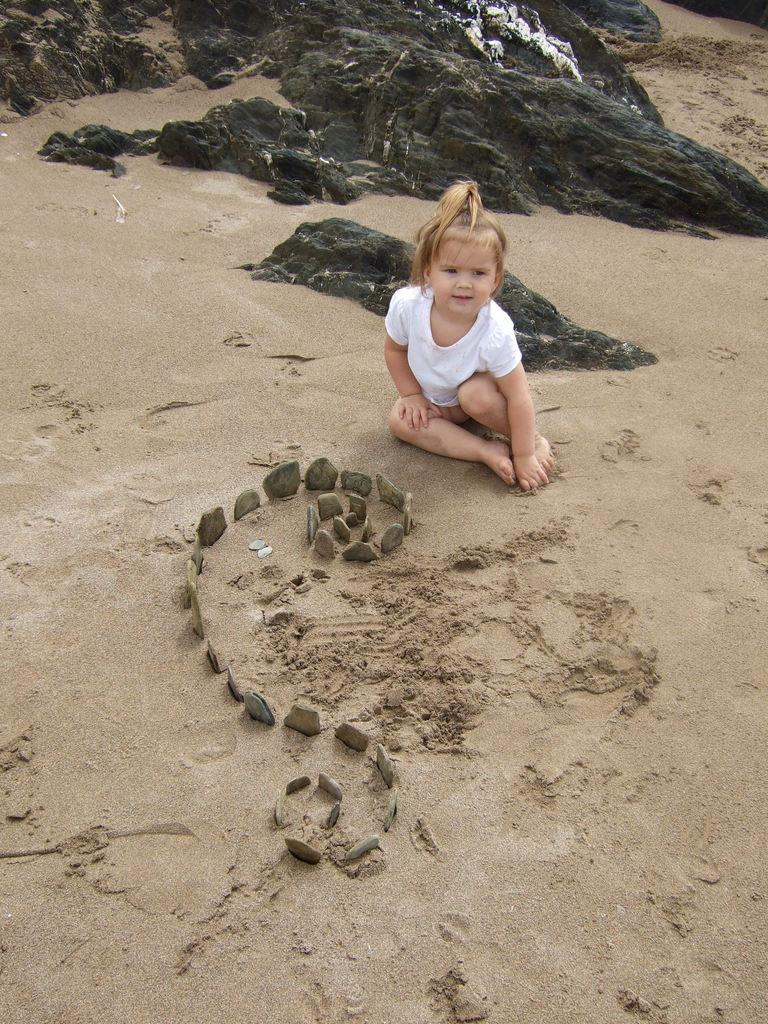What is the main subject of the image? There is a baby in the image. Where is the baby sitting? The baby is sitting on the sand. What can be seen in front of the baby? There are stones in front of the baby. What is located behind the baby? There are rocks behind the baby. What type of insect is crawling on the baby's forehead in the image? There is no insect present on the baby's forehead in the image. 